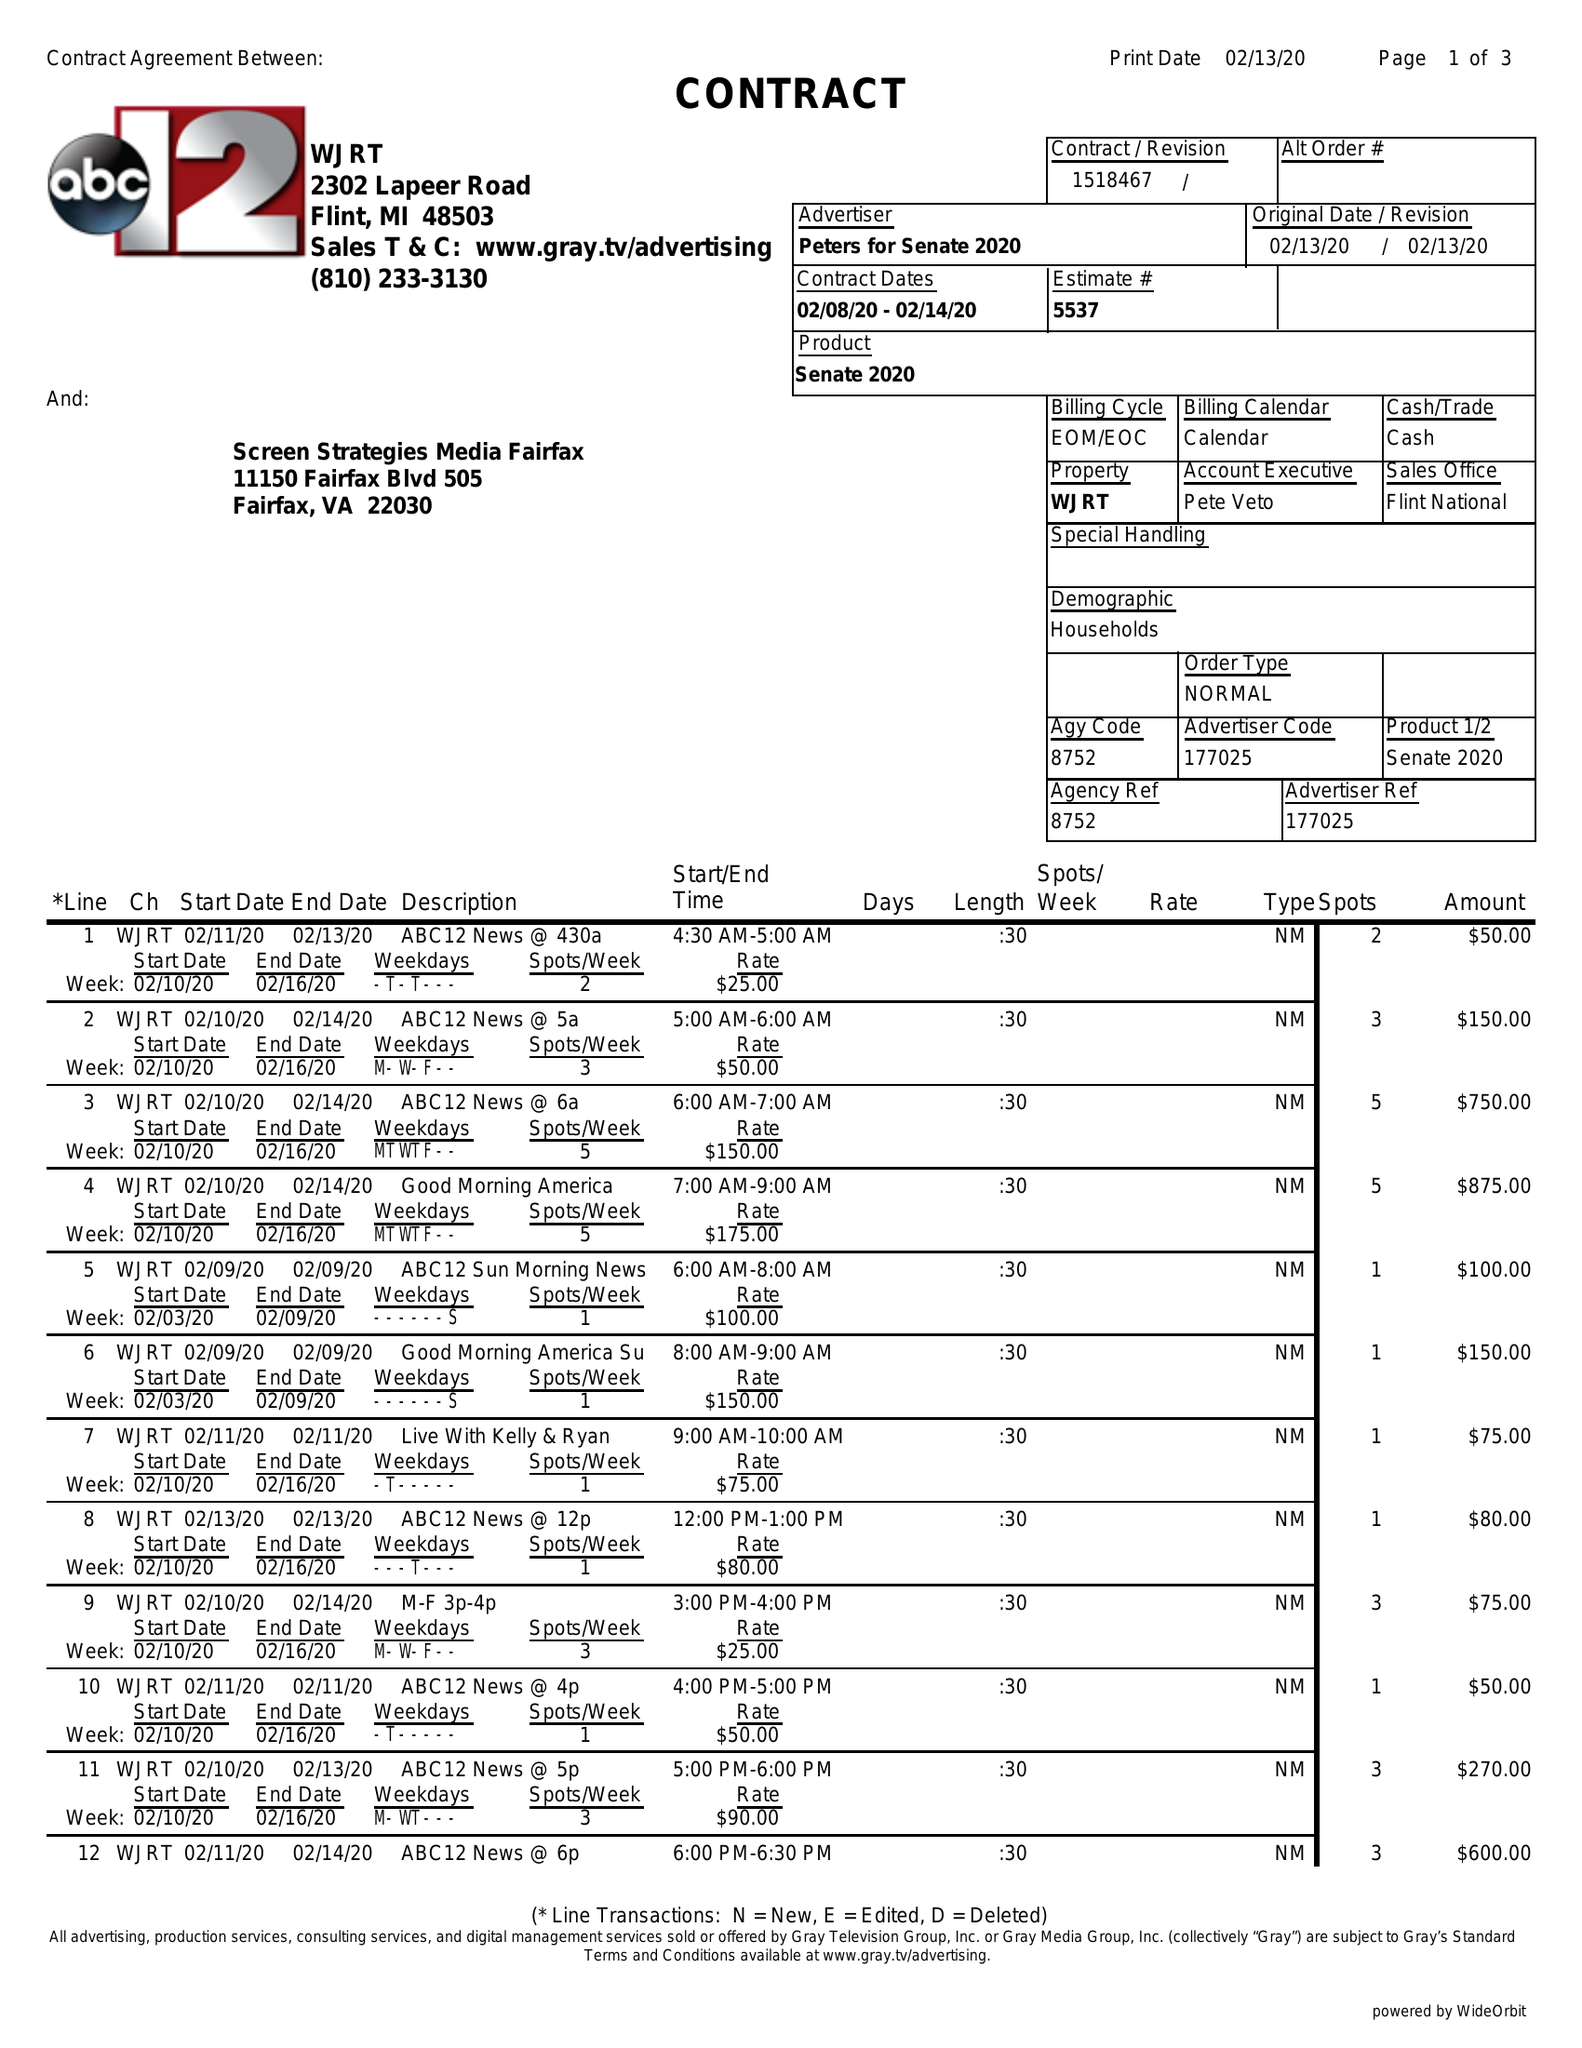What is the value for the contract_num?
Answer the question using a single word or phrase. 1518467 